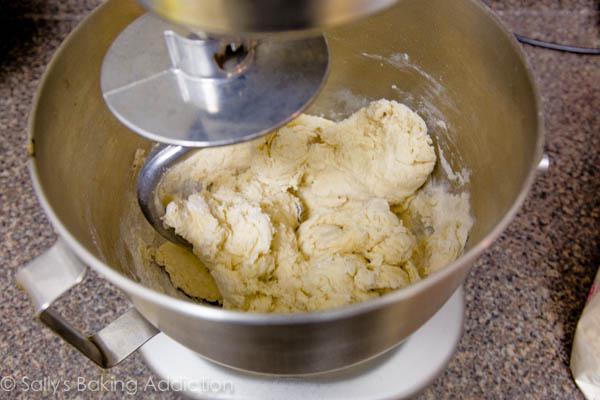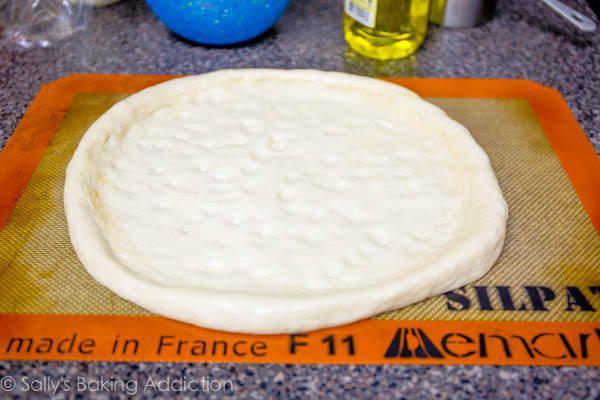The first image is the image on the left, the second image is the image on the right. Examine the images to the left and right. Is the description "The right image shows at least three round mounds of dough on floured brown paper." accurate? Answer yes or no. No. The first image is the image on the left, the second image is the image on the right. Evaluate the accuracy of this statement regarding the images: "One piece of dough is flattened.". Is it true? Answer yes or no. Yes. 